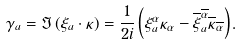Convert formula to latex. <formula><loc_0><loc_0><loc_500><loc_500>\gamma _ { a } = \Im \left ( \xi _ { a } \cdot \kappa \right ) = \frac { 1 } { 2 i } \left ( \xi ^ { \alpha } _ { a } \kappa _ { \alpha } - \overline { \xi } ^ { \overline { \alpha } } _ { a } \overline { \kappa } _ { \overline { \alpha } } \right ) .</formula> 